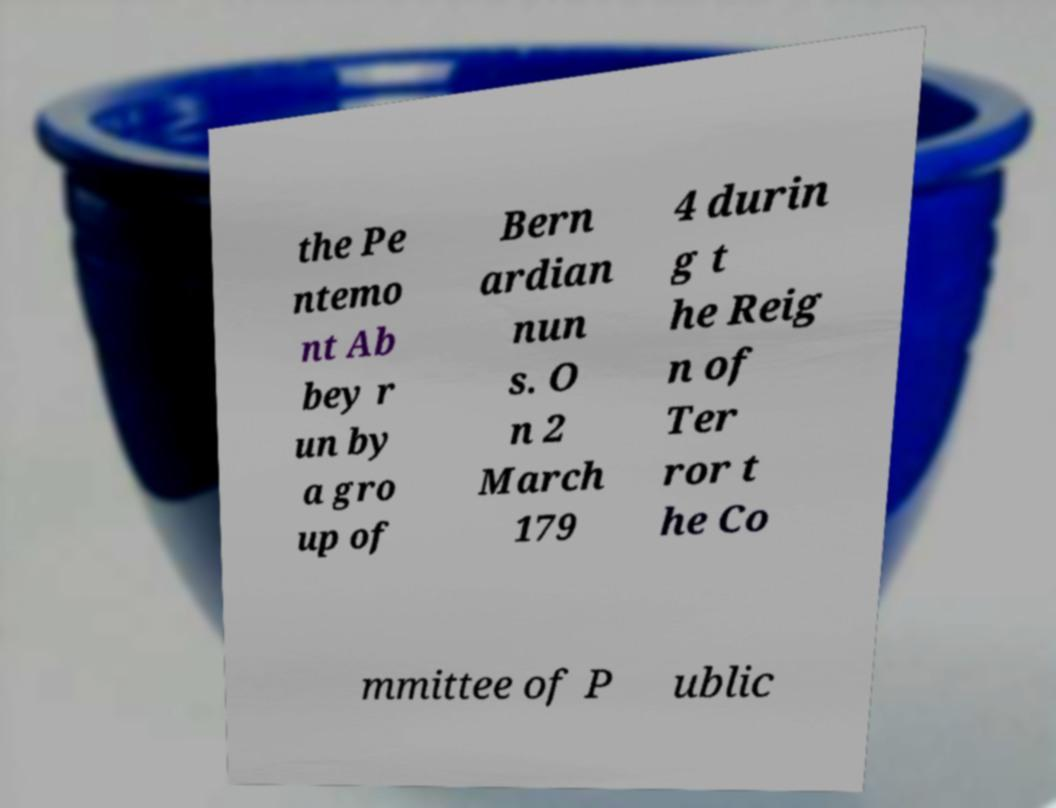For documentation purposes, I need the text within this image transcribed. Could you provide that? the Pe ntemo nt Ab bey r un by a gro up of Bern ardian nun s. O n 2 March 179 4 durin g t he Reig n of Ter ror t he Co mmittee of P ublic 